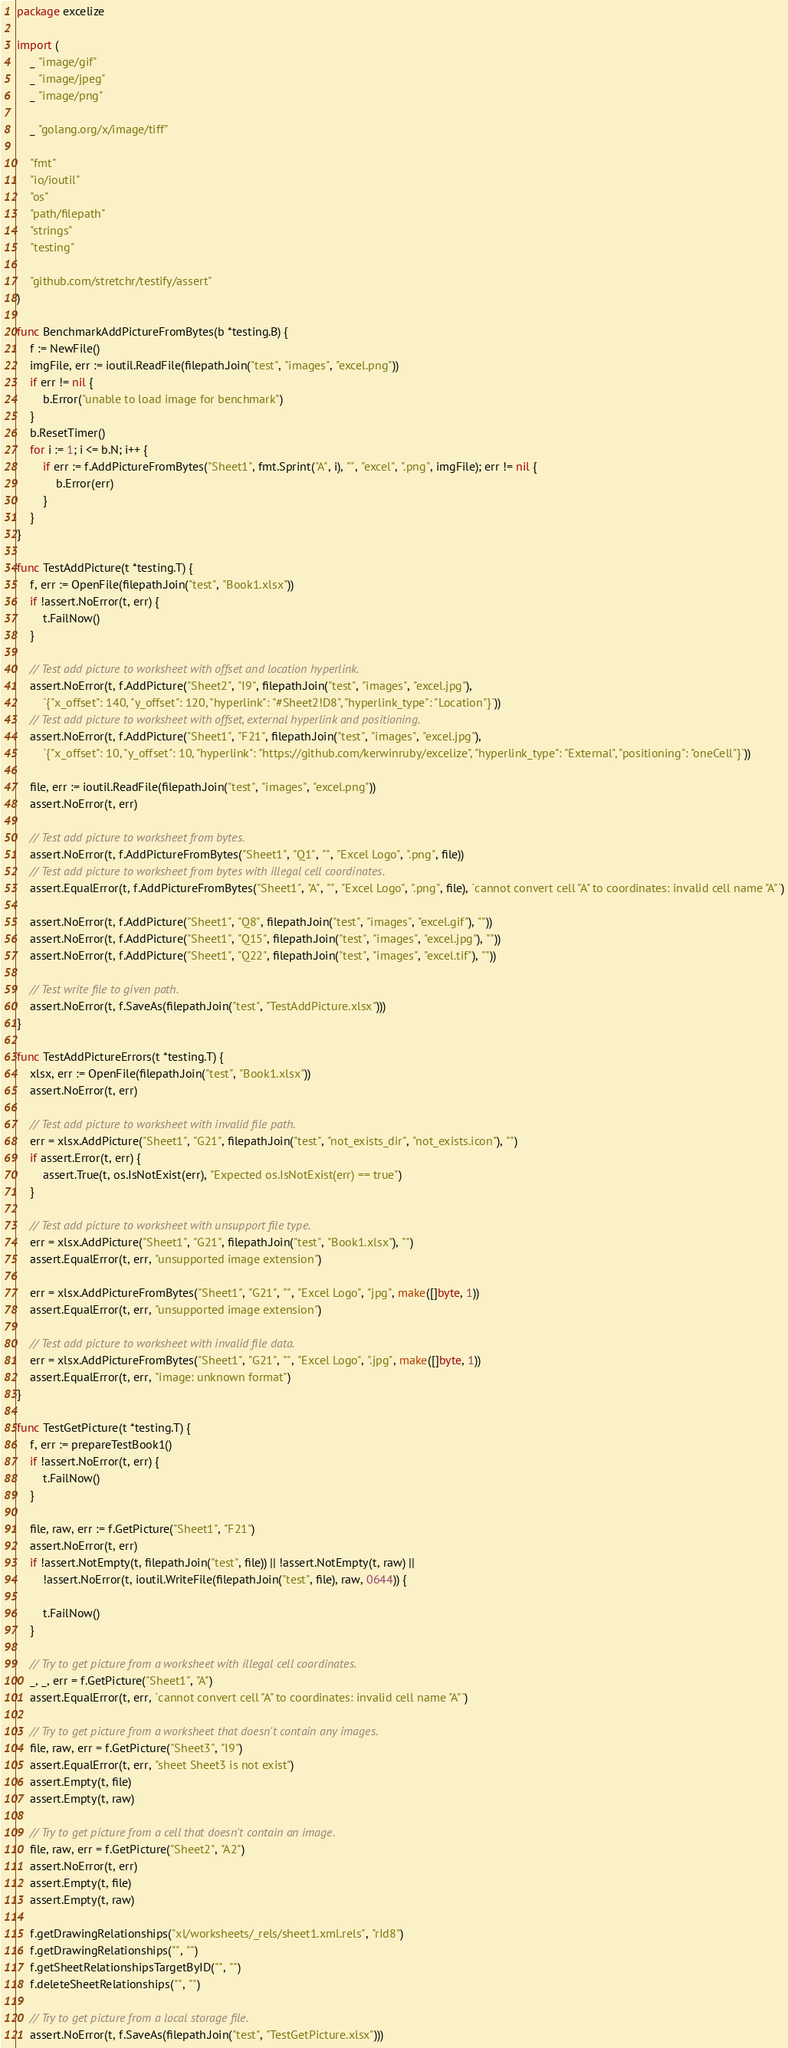Convert code to text. <code><loc_0><loc_0><loc_500><loc_500><_Go_>package excelize

import (
	_ "image/gif"
	_ "image/jpeg"
	_ "image/png"

	_ "golang.org/x/image/tiff"

	"fmt"
	"io/ioutil"
	"os"
	"path/filepath"
	"strings"
	"testing"

	"github.com/stretchr/testify/assert"
)

func BenchmarkAddPictureFromBytes(b *testing.B) {
	f := NewFile()
	imgFile, err := ioutil.ReadFile(filepath.Join("test", "images", "excel.png"))
	if err != nil {
		b.Error("unable to load image for benchmark")
	}
	b.ResetTimer()
	for i := 1; i <= b.N; i++ {
		if err := f.AddPictureFromBytes("Sheet1", fmt.Sprint("A", i), "", "excel", ".png", imgFile); err != nil {
			b.Error(err)
		}
	}
}

func TestAddPicture(t *testing.T) {
	f, err := OpenFile(filepath.Join("test", "Book1.xlsx"))
	if !assert.NoError(t, err) {
		t.FailNow()
	}

	// Test add picture to worksheet with offset and location hyperlink.
	assert.NoError(t, f.AddPicture("Sheet2", "I9", filepath.Join("test", "images", "excel.jpg"),
		`{"x_offset": 140, "y_offset": 120, "hyperlink": "#Sheet2!D8", "hyperlink_type": "Location"}`))
	// Test add picture to worksheet with offset, external hyperlink and positioning.
	assert.NoError(t, f.AddPicture("Sheet1", "F21", filepath.Join("test", "images", "excel.jpg"),
		`{"x_offset": 10, "y_offset": 10, "hyperlink": "https://github.com/kerwinruby/excelize", "hyperlink_type": "External", "positioning": "oneCell"}`))

	file, err := ioutil.ReadFile(filepath.Join("test", "images", "excel.png"))
	assert.NoError(t, err)

	// Test add picture to worksheet from bytes.
	assert.NoError(t, f.AddPictureFromBytes("Sheet1", "Q1", "", "Excel Logo", ".png", file))
	// Test add picture to worksheet from bytes with illegal cell coordinates.
	assert.EqualError(t, f.AddPictureFromBytes("Sheet1", "A", "", "Excel Logo", ".png", file), `cannot convert cell "A" to coordinates: invalid cell name "A"`)

	assert.NoError(t, f.AddPicture("Sheet1", "Q8", filepath.Join("test", "images", "excel.gif"), ""))
	assert.NoError(t, f.AddPicture("Sheet1", "Q15", filepath.Join("test", "images", "excel.jpg"), ""))
	assert.NoError(t, f.AddPicture("Sheet1", "Q22", filepath.Join("test", "images", "excel.tif"), ""))

	// Test write file to given path.
	assert.NoError(t, f.SaveAs(filepath.Join("test", "TestAddPicture.xlsx")))
}

func TestAddPictureErrors(t *testing.T) {
	xlsx, err := OpenFile(filepath.Join("test", "Book1.xlsx"))
	assert.NoError(t, err)

	// Test add picture to worksheet with invalid file path.
	err = xlsx.AddPicture("Sheet1", "G21", filepath.Join("test", "not_exists_dir", "not_exists.icon"), "")
	if assert.Error(t, err) {
		assert.True(t, os.IsNotExist(err), "Expected os.IsNotExist(err) == true")
	}

	// Test add picture to worksheet with unsupport file type.
	err = xlsx.AddPicture("Sheet1", "G21", filepath.Join("test", "Book1.xlsx"), "")
	assert.EqualError(t, err, "unsupported image extension")

	err = xlsx.AddPictureFromBytes("Sheet1", "G21", "", "Excel Logo", "jpg", make([]byte, 1))
	assert.EqualError(t, err, "unsupported image extension")

	// Test add picture to worksheet with invalid file data.
	err = xlsx.AddPictureFromBytes("Sheet1", "G21", "", "Excel Logo", ".jpg", make([]byte, 1))
	assert.EqualError(t, err, "image: unknown format")
}

func TestGetPicture(t *testing.T) {
	f, err := prepareTestBook1()
	if !assert.NoError(t, err) {
		t.FailNow()
	}

	file, raw, err := f.GetPicture("Sheet1", "F21")
	assert.NoError(t, err)
	if !assert.NotEmpty(t, filepath.Join("test", file)) || !assert.NotEmpty(t, raw) ||
		!assert.NoError(t, ioutil.WriteFile(filepath.Join("test", file), raw, 0644)) {

		t.FailNow()
	}

	// Try to get picture from a worksheet with illegal cell coordinates.
	_, _, err = f.GetPicture("Sheet1", "A")
	assert.EqualError(t, err, `cannot convert cell "A" to coordinates: invalid cell name "A"`)

	// Try to get picture from a worksheet that doesn't contain any images.
	file, raw, err = f.GetPicture("Sheet3", "I9")
	assert.EqualError(t, err, "sheet Sheet3 is not exist")
	assert.Empty(t, file)
	assert.Empty(t, raw)

	// Try to get picture from a cell that doesn't contain an image.
	file, raw, err = f.GetPicture("Sheet2", "A2")
	assert.NoError(t, err)
	assert.Empty(t, file)
	assert.Empty(t, raw)

	f.getDrawingRelationships("xl/worksheets/_rels/sheet1.xml.rels", "rId8")
	f.getDrawingRelationships("", "")
	f.getSheetRelationshipsTargetByID("", "")
	f.deleteSheetRelationships("", "")

	// Try to get picture from a local storage file.
	assert.NoError(t, f.SaveAs(filepath.Join("test", "TestGetPicture.xlsx")))
</code> 